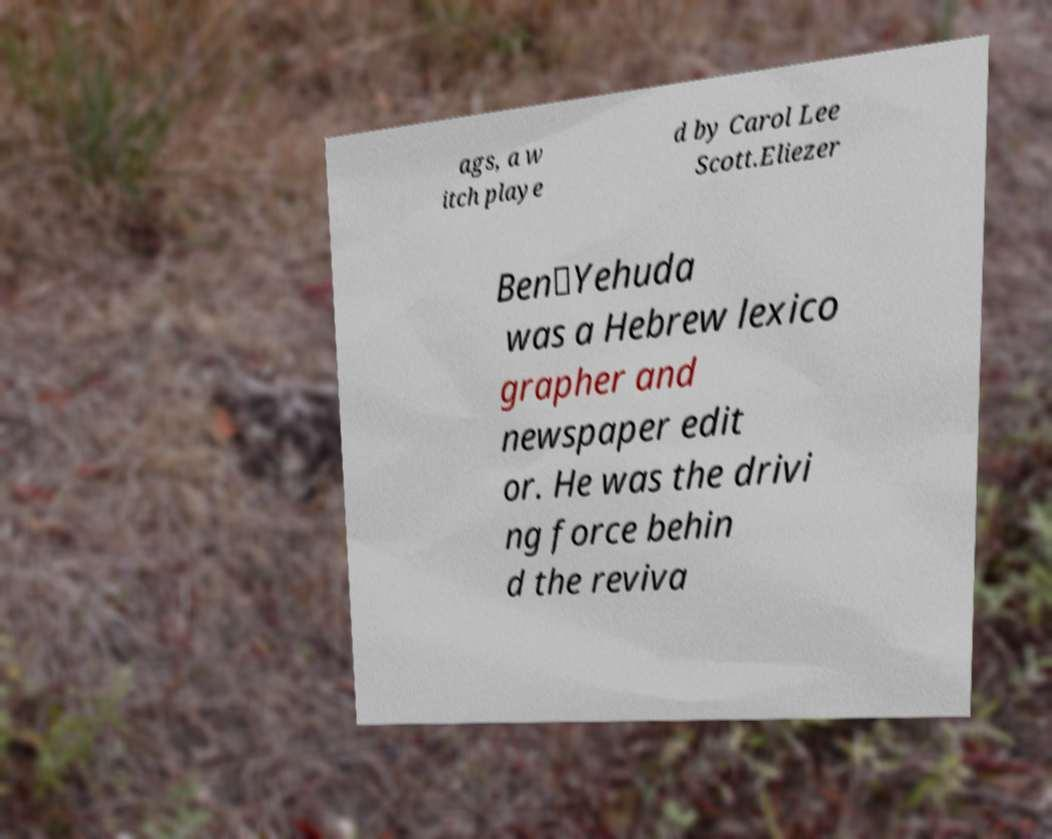There's text embedded in this image that I need extracted. Can you transcribe it verbatim? ags, a w itch playe d by Carol Lee Scott.Eliezer Ben‑Yehuda was a Hebrew lexico grapher and newspaper edit or. He was the drivi ng force behin d the reviva 